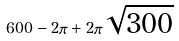Convert formula to latex. <formula><loc_0><loc_0><loc_500><loc_500>6 0 0 - 2 \pi + 2 \pi \sqrt { 3 0 0 }</formula> 